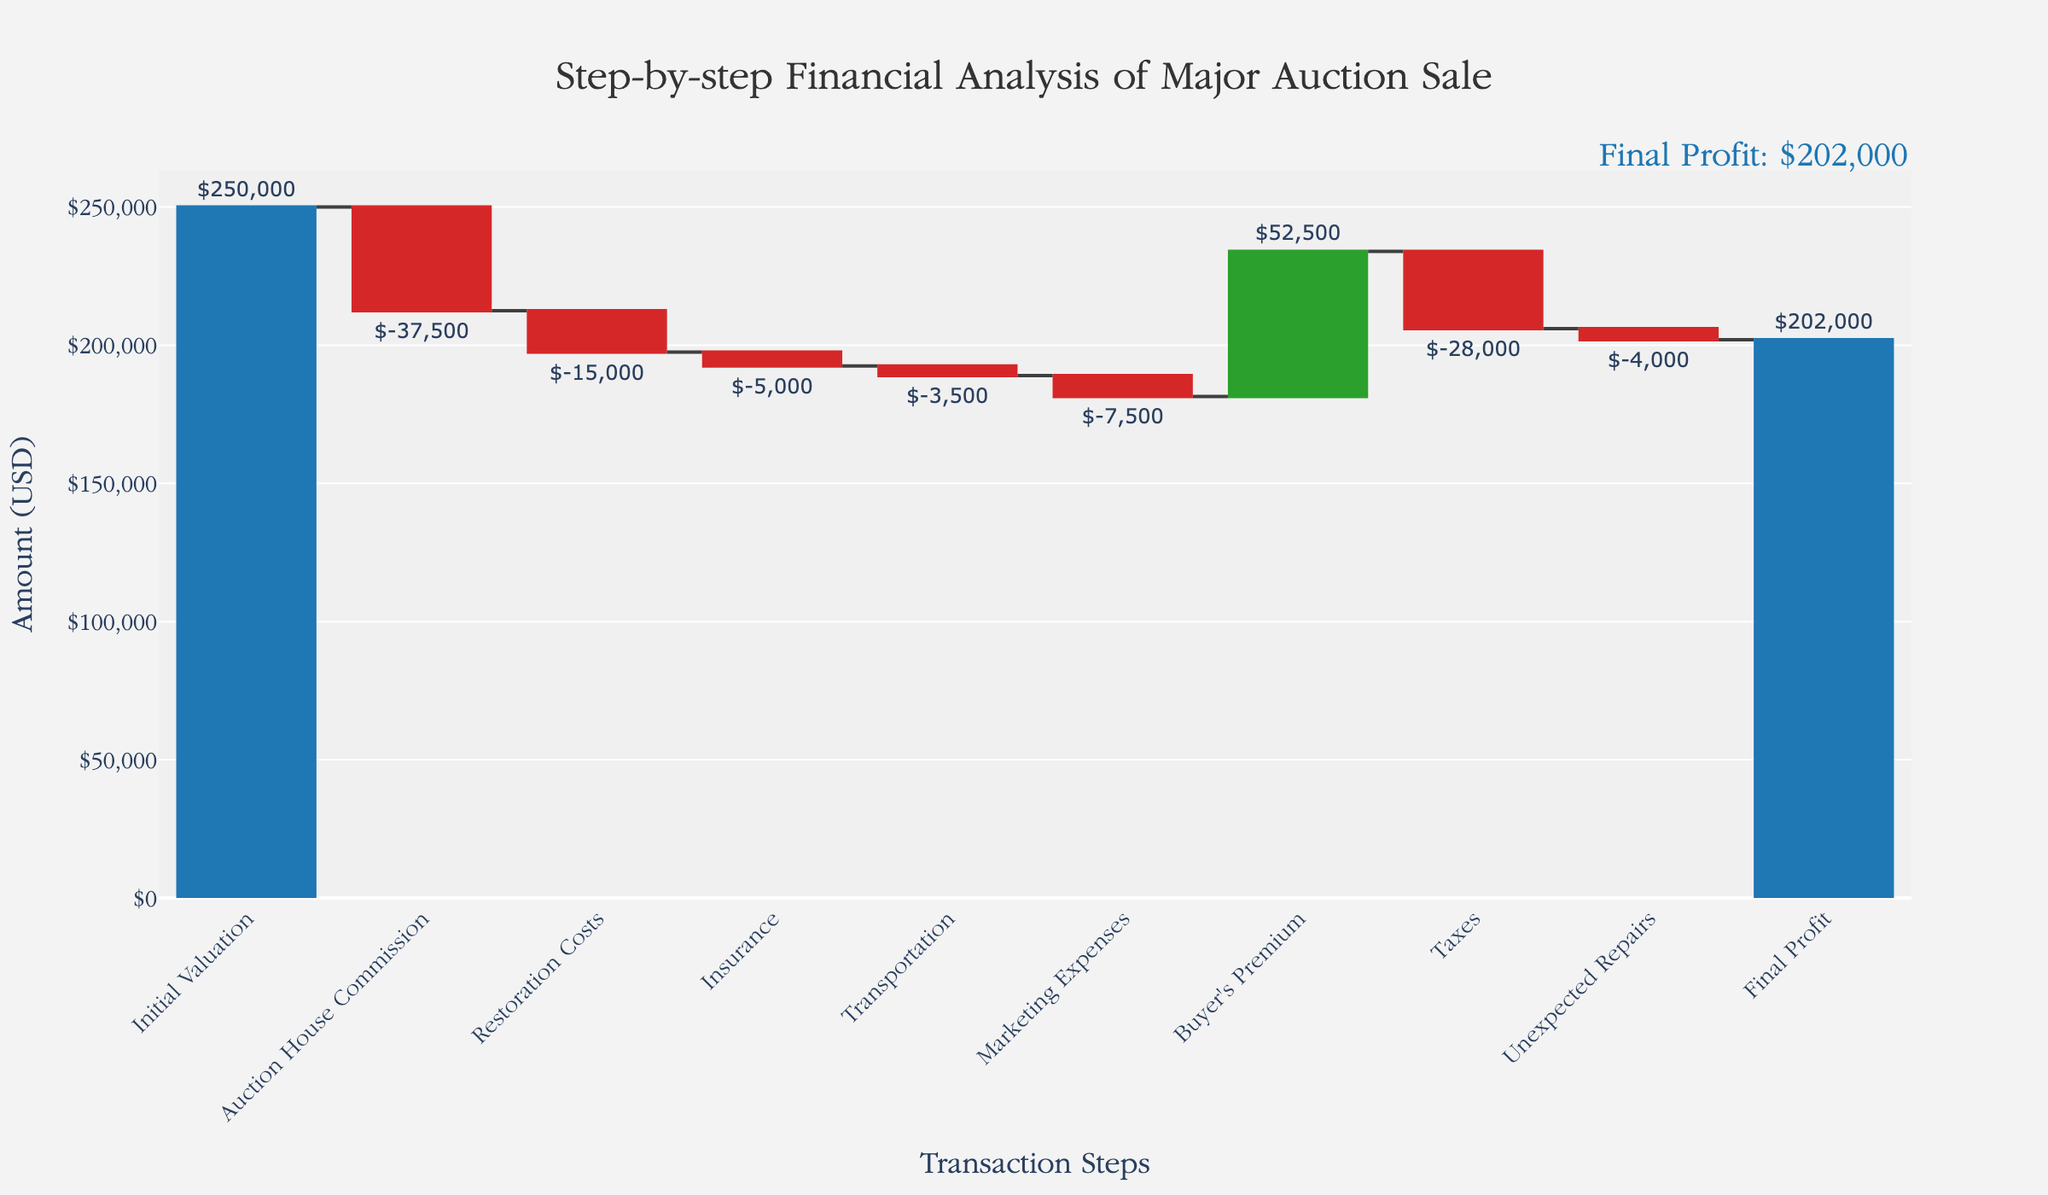What is the title of the chart? The title is a textual element usually placed at the top of the chart. It can be directly read without any calculations.
Answer: Step-by-step Financial Analysis of Major Auction Sale What is the initial valuation amount shown in the chart? The initial valuation amount is labeled at the first data point on the left-hand side of the chart.
Answer: $250,000 What category has the highest value among all expenses? All expenses have negative values, and the highest (least negative) value can be identified by looking at the tallest decreasing bar.
Answer: Auction House Commission What is the total of all expenses before adding the buyer's premium? To find the total of all expenses, sum the negative values. Add -37,500, -15,000, -5,000, -3,500, -7,500, -28,000, and -4,000.
Answer: -100,500 How does the buyer's premium compare to the auction house commission? Compare the height of the bars representing the buyer's premium and the auction house commission to determine the greater value.
Answer: Buyer's Premium is greater What's the overall impact of additional costs (restoration, insurance, transportation, marketing, taxes, unexpected repairs) on the initial valuation? Sum the values of all additional costs post-initial valuation to find their aggregated impact. -15,000 + -5,000 + -3,500 + -7,500 + -28,000 + -4,000 = -63,000
Answer: -$63,000 What is the final profit at the end of the analysis? The final profit is shown as the last value on the chart, labeled as ‘Final Profit’.
Answer: $202,000 How much does the buyer's premium contribute to offsetting the expenses? The buyer's premium is a positive value in the chart and is added directly (+$52,500) to the overall analysis to offset the expenses.
Answer: $52,500 What is the net gain or loss after auction house commission and before adding buyer's premium? The net gain/loss can be calculated by subtracting the auction house commission from the initial valuation. $250,000 - $37,500 = $212,500
Answer: $212,500 What is the cumulative impact of auction house commission, insurance, marketing, and taxes combined on the initial valuation? Sum the impact of auction house commission, insurance, marketing expenses, and taxes. -37,500 + -5,000 + -7,500 + -28,000 = -78,000
Answer: -$78,000 